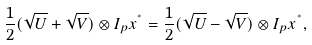Convert formula to latex. <formula><loc_0><loc_0><loc_500><loc_500>\frac { 1 } { 2 } ( \sqrt { U } + \sqrt { V } ) \otimes I _ { p } x ^ { ^ { * } } = \frac { 1 } { 2 } ( \sqrt { U } - \sqrt { V } ) \otimes I _ { p } x ^ { ^ { * } } ,</formula> 